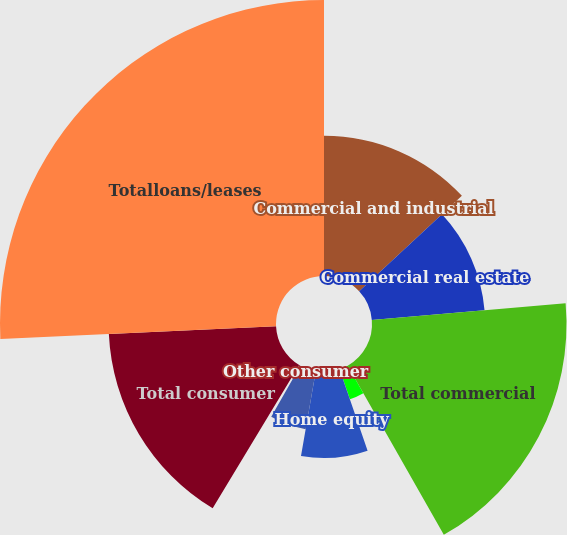Convert chart. <chart><loc_0><loc_0><loc_500><loc_500><pie_chart><fcel>Commercial and industrial<fcel>Commercial real estate<fcel>Total commercial<fcel>Automobile loansand leases<fcel>Home equity<fcel>Residential mortgage<fcel>Other consumer<fcel>Total consumer<fcel>Totalloans/leases<nl><fcel>13.08%<fcel>10.55%<fcel>18.14%<fcel>2.95%<fcel>8.02%<fcel>5.48%<fcel>0.42%<fcel>15.61%<fcel>25.74%<nl></chart> 